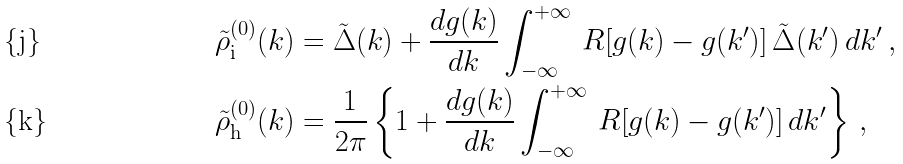<formula> <loc_0><loc_0><loc_500><loc_500>\tilde { \rho } ^ { ( 0 ) } _ { \text {i} } ( k ) & = \tilde { \Delta } ( k ) + \frac { d g ( k ) } { d k } \int _ { - \infty } ^ { + \infty } \, R [ g ( k ) - g ( k ^ { \prime } ) ] \, \tilde { \Delta } ( k ^ { \prime } ) \, d k ^ { \prime } \, , \\ \tilde { \rho } ^ { ( 0 ) } _ { \text {h} } ( k ) & = \frac { 1 } { 2 \pi } \left \{ 1 + \frac { d g ( k ) } { d k } \int _ { - \infty } ^ { + \infty } \, R [ g ( k ) - g ( k ^ { \prime } ) ] \, d k ^ { \prime } \right \} \, ,</formula> 